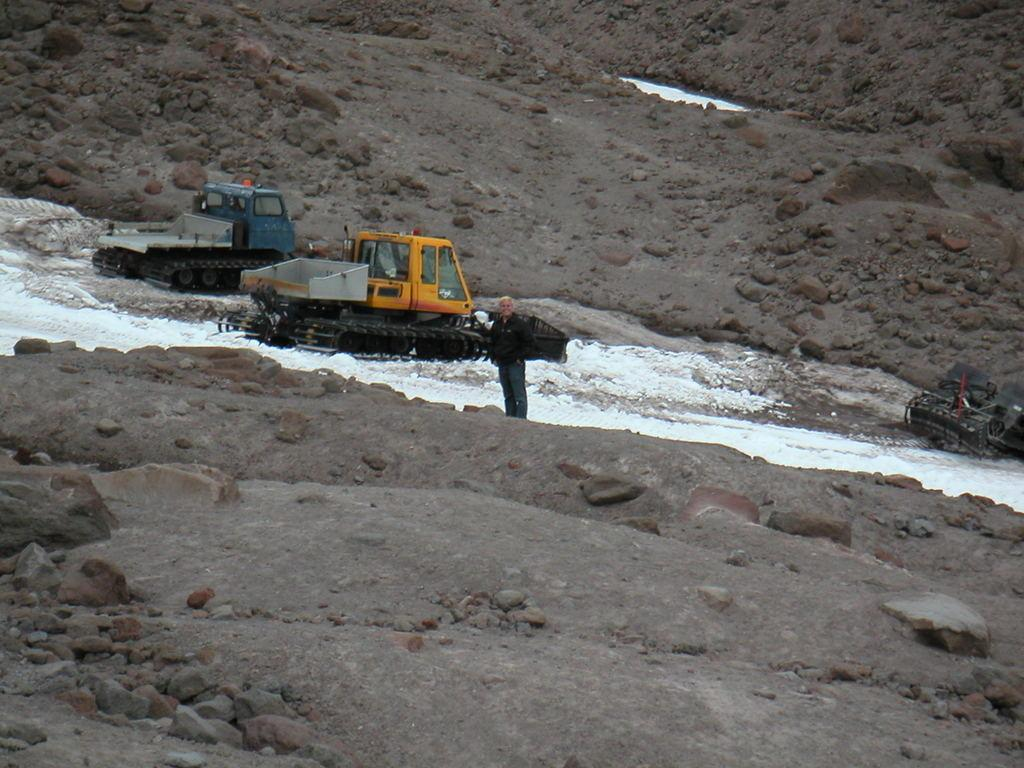What is the main subject of the image? There is a person standing in the image. What else can be seen in the image besides the person? There are vehicles and snow visible in the image. Are there any natural elements present in the image? Yes, rocks are visible in the image. How many chairs can be seen in the image? There are no chairs present in the image. What type of crate is visible in the image? There is no crate present in the image. 